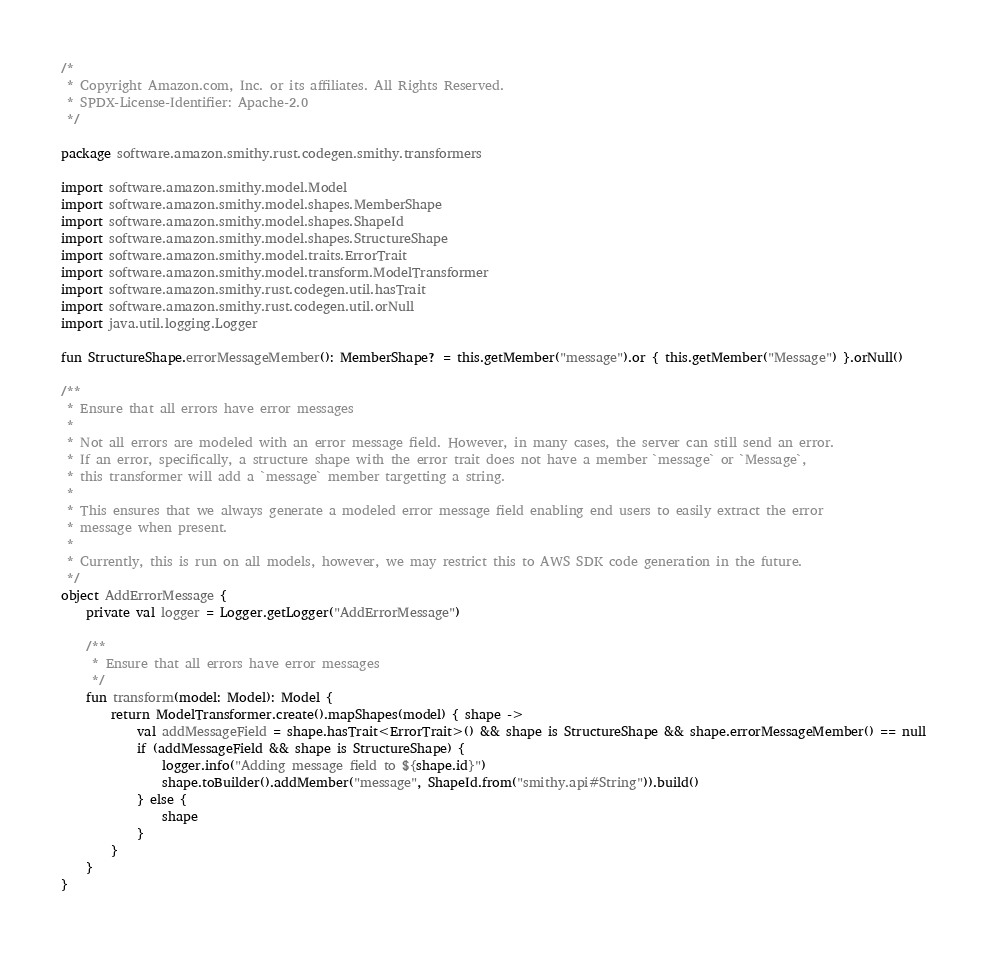<code> <loc_0><loc_0><loc_500><loc_500><_Kotlin_>/*
 * Copyright Amazon.com, Inc. or its affiliates. All Rights Reserved.
 * SPDX-License-Identifier: Apache-2.0
 */

package software.amazon.smithy.rust.codegen.smithy.transformers

import software.amazon.smithy.model.Model
import software.amazon.smithy.model.shapes.MemberShape
import software.amazon.smithy.model.shapes.ShapeId
import software.amazon.smithy.model.shapes.StructureShape
import software.amazon.smithy.model.traits.ErrorTrait
import software.amazon.smithy.model.transform.ModelTransformer
import software.amazon.smithy.rust.codegen.util.hasTrait
import software.amazon.smithy.rust.codegen.util.orNull
import java.util.logging.Logger

fun StructureShape.errorMessageMember(): MemberShape? = this.getMember("message").or { this.getMember("Message") }.orNull()

/**
 * Ensure that all errors have error messages
 *
 * Not all errors are modeled with an error message field. However, in many cases, the server can still send an error.
 * If an error, specifically, a structure shape with the error trait does not have a member `message` or `Message`,
 * this transformer will add a `message` member targetting a string.
 *
 * This ensures that we always generate a modeled error message field enabling end users to easily extract the error
 * message when present.
 *
 * Currently, this is run on all models, however, we may restrict this to AWS SDK code generation in the future.
 */
object AddErrorMessage {
    private val logger = Logger.getLogger("AddErrorMessage")

    /**
     * Ensure that all errors have error messages
     */
    fun transform(model: Model): Model {
        return ModelTransformer.create().mapShapes(model) { shape ->
            val addMessageField = shape.hasTrait<ErrorTrait>() && shape is StructureShape && shape.errorMessageMember() == null
            if (addMessageField && shape is StructureShape) {
                logger.info("Adding message field to ${shape.id}")
                shape.toBuilder().addMember("message", ShapeId.from("smithy.api#String")).build()
            } else {
                shape
            }
        }
    }
}
</code> 